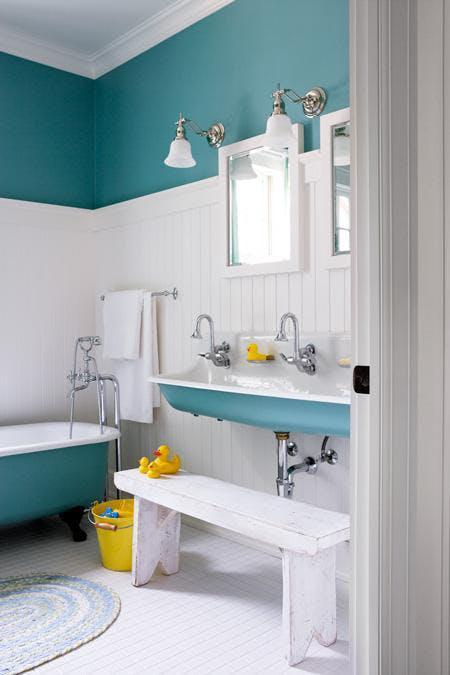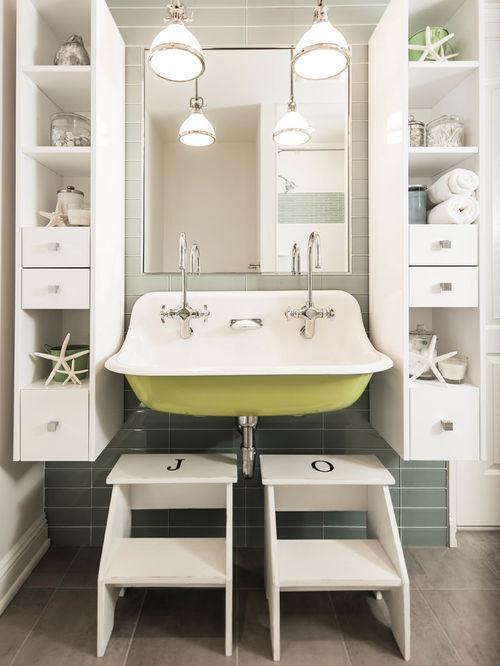The first image is the image on the left, the second image is the image on the right. For the images shown, is this caption "porcelain sinks are colored underneath" true? Answer yes or no. Yes. The first image is the image on the left, the second image is the image on the right. Considering the images on both sides, is "One of these images contains two or more footstools, in front of a large sink with multiple faucets." valid? Answer yes or no. Yes. 